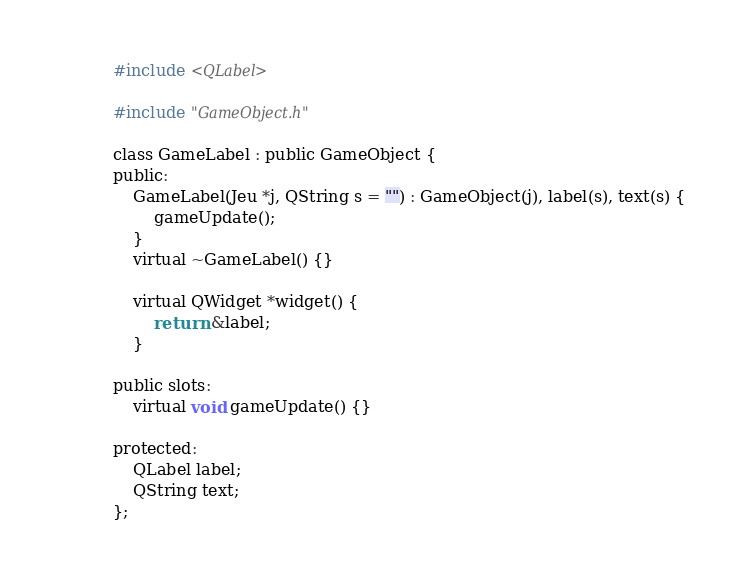Convert code to text. <code><loc_0><loc_0><loc_500><loc_500><_C_>#include <QLabel>

#include "GameObject.h"

class GameLabel : public GameObject {
public:
	GameLabel(Jeu *j, QString s = "") : GameObject(j), label(s), text(s) {
		gameUpdate();
	}
	virtual ~GameLabel() {}

	virtual QWidget *widget() {
		return &label;
	}

public slots:
	virtual void gameUpdate() {}

protected:
	QLabel label;
	QString text;
};
</code> 